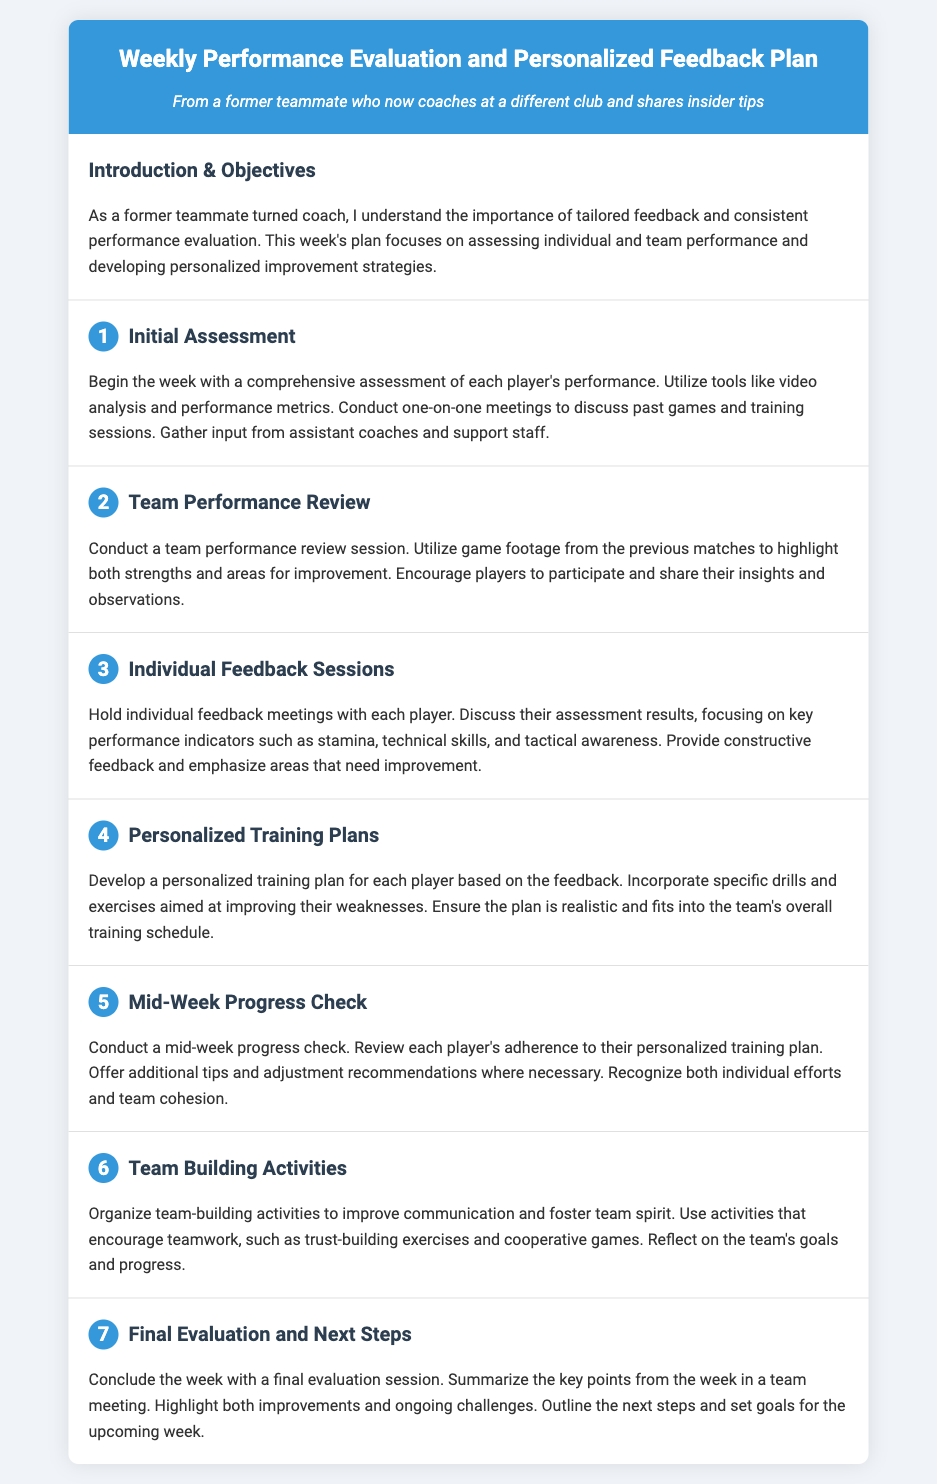What is the title of the document? The title is stated in the header section of the document.
Answer: Weekly Performance Evaluation and Personalized Feedback Plan How many days are outlined in the itinerary? Each section is numbered from 1 to 7, indicating the number of days.
Answer: 7 What is the main focus of the week? The introduction section highlights the primary emphasis of the document.
Answer: Assessing individual and team performance What type of activities are suggested for day six? The content of the sixth section provides specific types of activities.
Answer: Team-building activities What is one key performance indicator discussed during Individual Feedback Sessions? The section mentions specific metrics for assessment in the feedback meetings.
Answer: Stamina How is player progress checked during the week? The document describes how progress checks are conducted mid-week.
Answer: Mid-week progress check What will be highlighted in the final evaluation session? The conclusion section mentions specific elements to be covered in the final evaluation.
Answer: Improvements and ongoing challenges What should be included in the personalized training plans? The document specifies actionable components in the personalized training plans.
Answer: Specific drills and exercises 